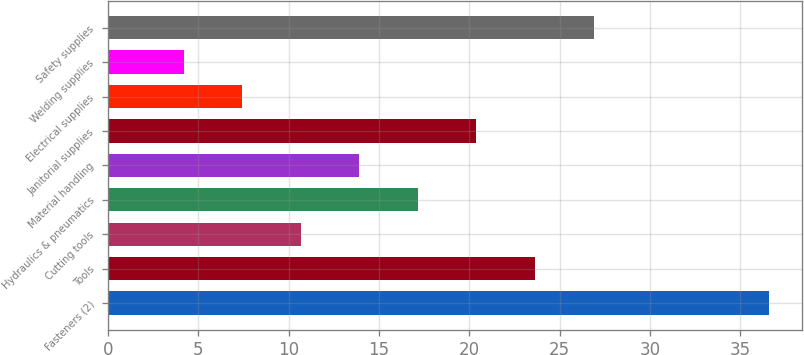<chart> <loc_0><loc_0><loc_500><loc_500><bar_chart><fcel>Fasteners (2)<fcel>Tools<fcel>Cutting tools<fcel>Hydraulics & pneumatics<fcel>Material handling<fcel>Janitorial supplies<fcel>Electrical supplies<fcel>Welding supplies<fcel>Safety supplies<nl><fcel>36.6<fcel>23.64<fcel>10.68<fcel>17.16<fcel>13.92<fcel>20.4<fcel>7.44<fcel>4.2<fcel>26.88<nl></chart> 